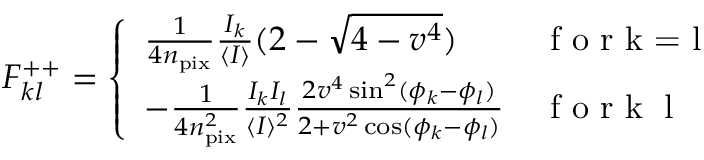<formula> <loc_0><loc_0><loc_500><loc_500>F _ { k l } ^ { + + } = \left \{ \begin{array} { l l } { \frac { 1 } { 4 n _ { p i x } } \frac { I _ { k } } { \langle I \rangle } ( 2 - \sqrt { 4 - v ^ { 4 } } ) } & { f o r k = l } \\ { - \frac { 1 } { 4 n _ { p i x } ^ { 2 } } \frac { I _ { k } I _ { l } } { \langle I \rangle ^ { 2 } } \frac { 2 v ^ { 4 } \sin ^ { 2 } ( \phi _ { k } - \phi _ { l } ) } { 2 + v ^ { 2 } \cos ( \phi _ { k } - \phi _ { l } ) } } & { f o r k \neq l } \end{array}</formula> 